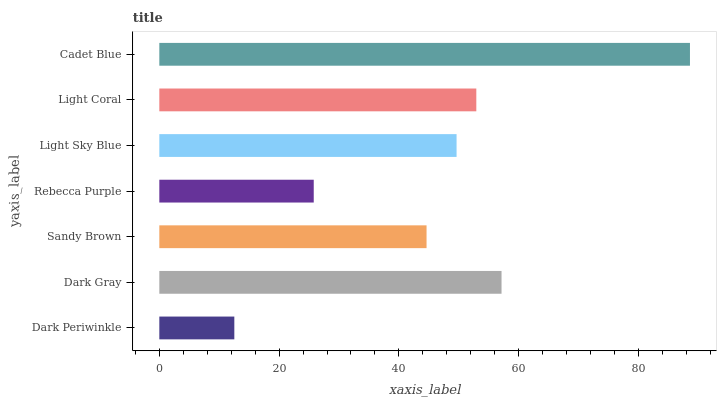Is Dark Periwinkle the minimum?
Answer yes or no. Yes. Is Cadet Blue the maximum?
Answer yes or no. Yes. Is Dark Gray the minimum?
Answer yes or no. No. Is Dark Gray the maximum?
Answer yes or no. No. Is Dark Gray greater than Dark Periwinkle?
Answer yes or no. Yes. Is Dark Periwinkle less than Dark Gray?
Answer yes or no. Yes. Is Dark Periwinkle greater than Dark Gray?
Answer yes or no. No. Is Dark Gray less than Dark Periwinkle?
Answer yes or no. No. Is Light Sky Blue the high median?
Answer yes or no. Yes. Is Light Sky Blue the low median?
Answer yes or no. Yes. Is Rebecca Purple the high median?
Answer yes or no. No. Is Sandy Brown the low median?
Answer yes or no. No. 